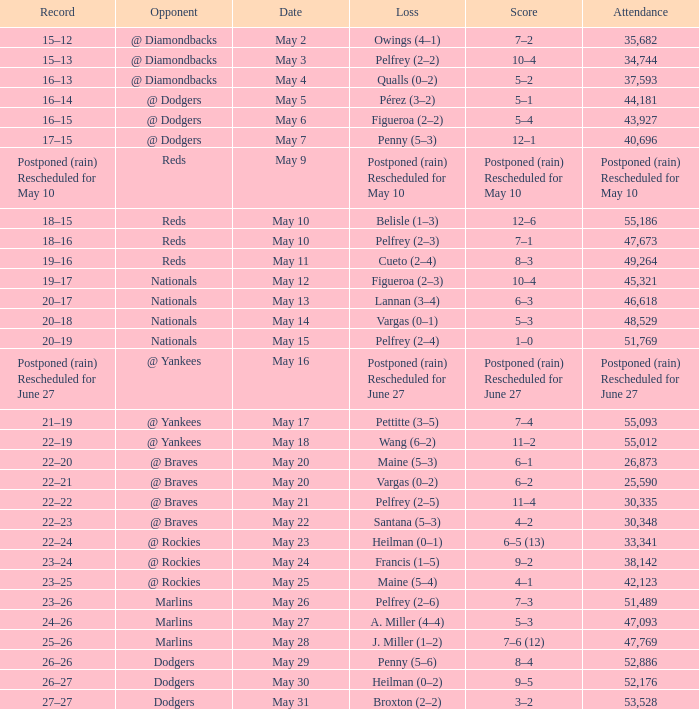Record of 19–16 occurred on what date? May 11. 